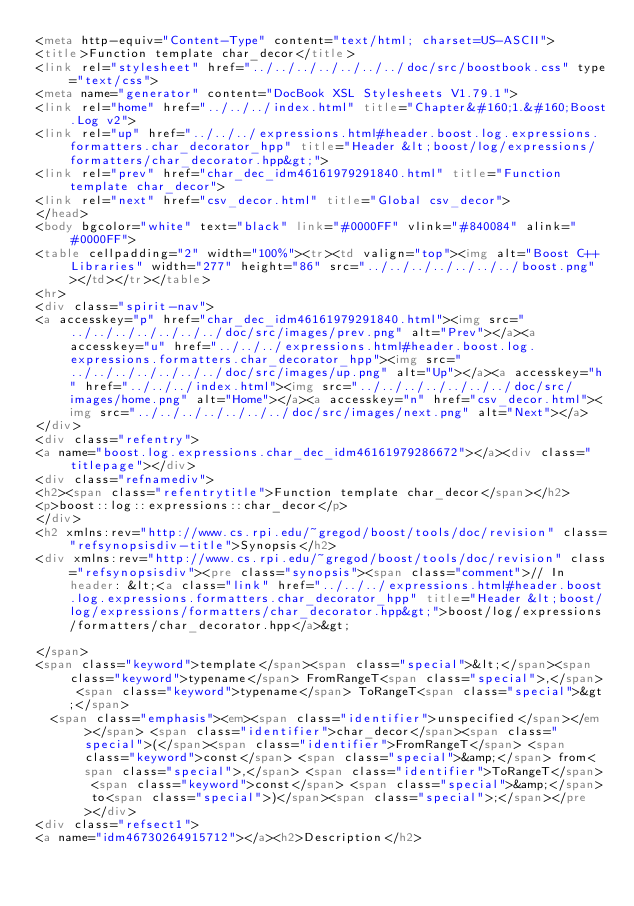<code> <loc_0><loc_0><loc_500><loc_500><_HTML_><meta http-equiv="Content-Type" content="text/html; charset=US-ASCII">
<title>Function template char_decor</title>
<link rel="stylesheet" href="../../../../../../../doc/src/boostbook.css" type="text/css">
<meta name="generator" content="DocBook XSL Stylesheets V1.79.1">
<link rel="home" href="../../../index.html" title="Chapter&#160;1.&#160;Boost.Log v2">
<link rel="up" href="../../../expressions.html#header.boost.log.expressions.formatters.char_decorator_hpp" title="Header &lt;boost/log/expressions/formatters/char_decorator.hpp&gt;">
<link rel="prev" href="char_dec_idm46161979291840.html" title="Function template char_decor">
<link rel="next" href="csv_decor.html" title="Global csv_decor">
</head>
<body bgcolor="white" text="black" link="#0000FF" vlink="#840084" alink="#0000FF">
<table cellpadding="2" width="100%"><tr><td valign="top"><img alt="Boost C++ Libraries" width="277" height="86" src="../../../../../../../boost.png"></td></tr></table>
<hr>
<div class="spirit-nav">
<a accesskey="p" href="char_dec_idm46161979291840.html"><img src="../../../../../../../doc/src/images/prev.png" alt="Prev"></a><a accesskey="u" href="../../../expressions.html#header.boost.log.expressions.formatters.char_decorator_hpp"><img src="../../../../../../../doc/src/images/up.png" alt="Up"></a><a accesskey="h" href="../../../index.html"><img src="../../../../../../../doc/src/images/home.png" alt="Home"></a><a accesskey="n" href="csv_decor.html"><img src="../../../../../../../doc/src/images/next.png" alt="Next"></a>
</div>
<div class="refentry">
<a name="boost.log.expressions.char_dec_idm46161979286672"></a><div class="titlepage"></div>
<div class="refnamediv">
<h2><span class="refentrytitle">Function template char_decor</span></h2>
<p>boost::log::expressions::char_decor</p>
</div>
<h2 xmlns:rev="http://www.cs.rpi.edu/~gregod/boost/tools/doc/revision" class="refsynopsisdiv-title">Synopsis</h2>
<div xmlns:rev="http://www.cs.rpi.edu/~gregod/boost/tools/doc/revision" class="refsynopsisdiv"><pre class="synopsis"><span class="comment">// In header: &lt;<a class="link" href="../../../expressions.html#header.boost.log.expressions.formatters.char_decorator_hpp" title="Header &lt;boost/log/expressions/formatters/char_decorator.hpp&gt;">boost/log/expressions/formatters/char_decorator.hpp</a>&gt;

</span>
<span class="keyword">template</span><span class="special">&lt;</span><span class="keyword">typename</span> FromRangeT<span class="special">,</span> <span class="keyword">typename</span> ToRangeT<span class="special">&gt;</span> 
  <span class="emphasis"><em><span class="identifier">unspecified</span></em></span> <span class="identifier">char_decor</span><span class="special">(</span><span class="identifier">FromRangeT</span> <span class="keyword">const</span> <span class="special">&amp;</span> from<span class="special">,</span> <span class="identifier">ToRangeT</span> <span class="keyword">const</span> <span class="special">&amp;</span> to<span class="special">)</span><span class="special">;</span></pre></div>
<div class="refsect1">
<a name="idm46730264915712"></a><h2>Description</h2></code> 